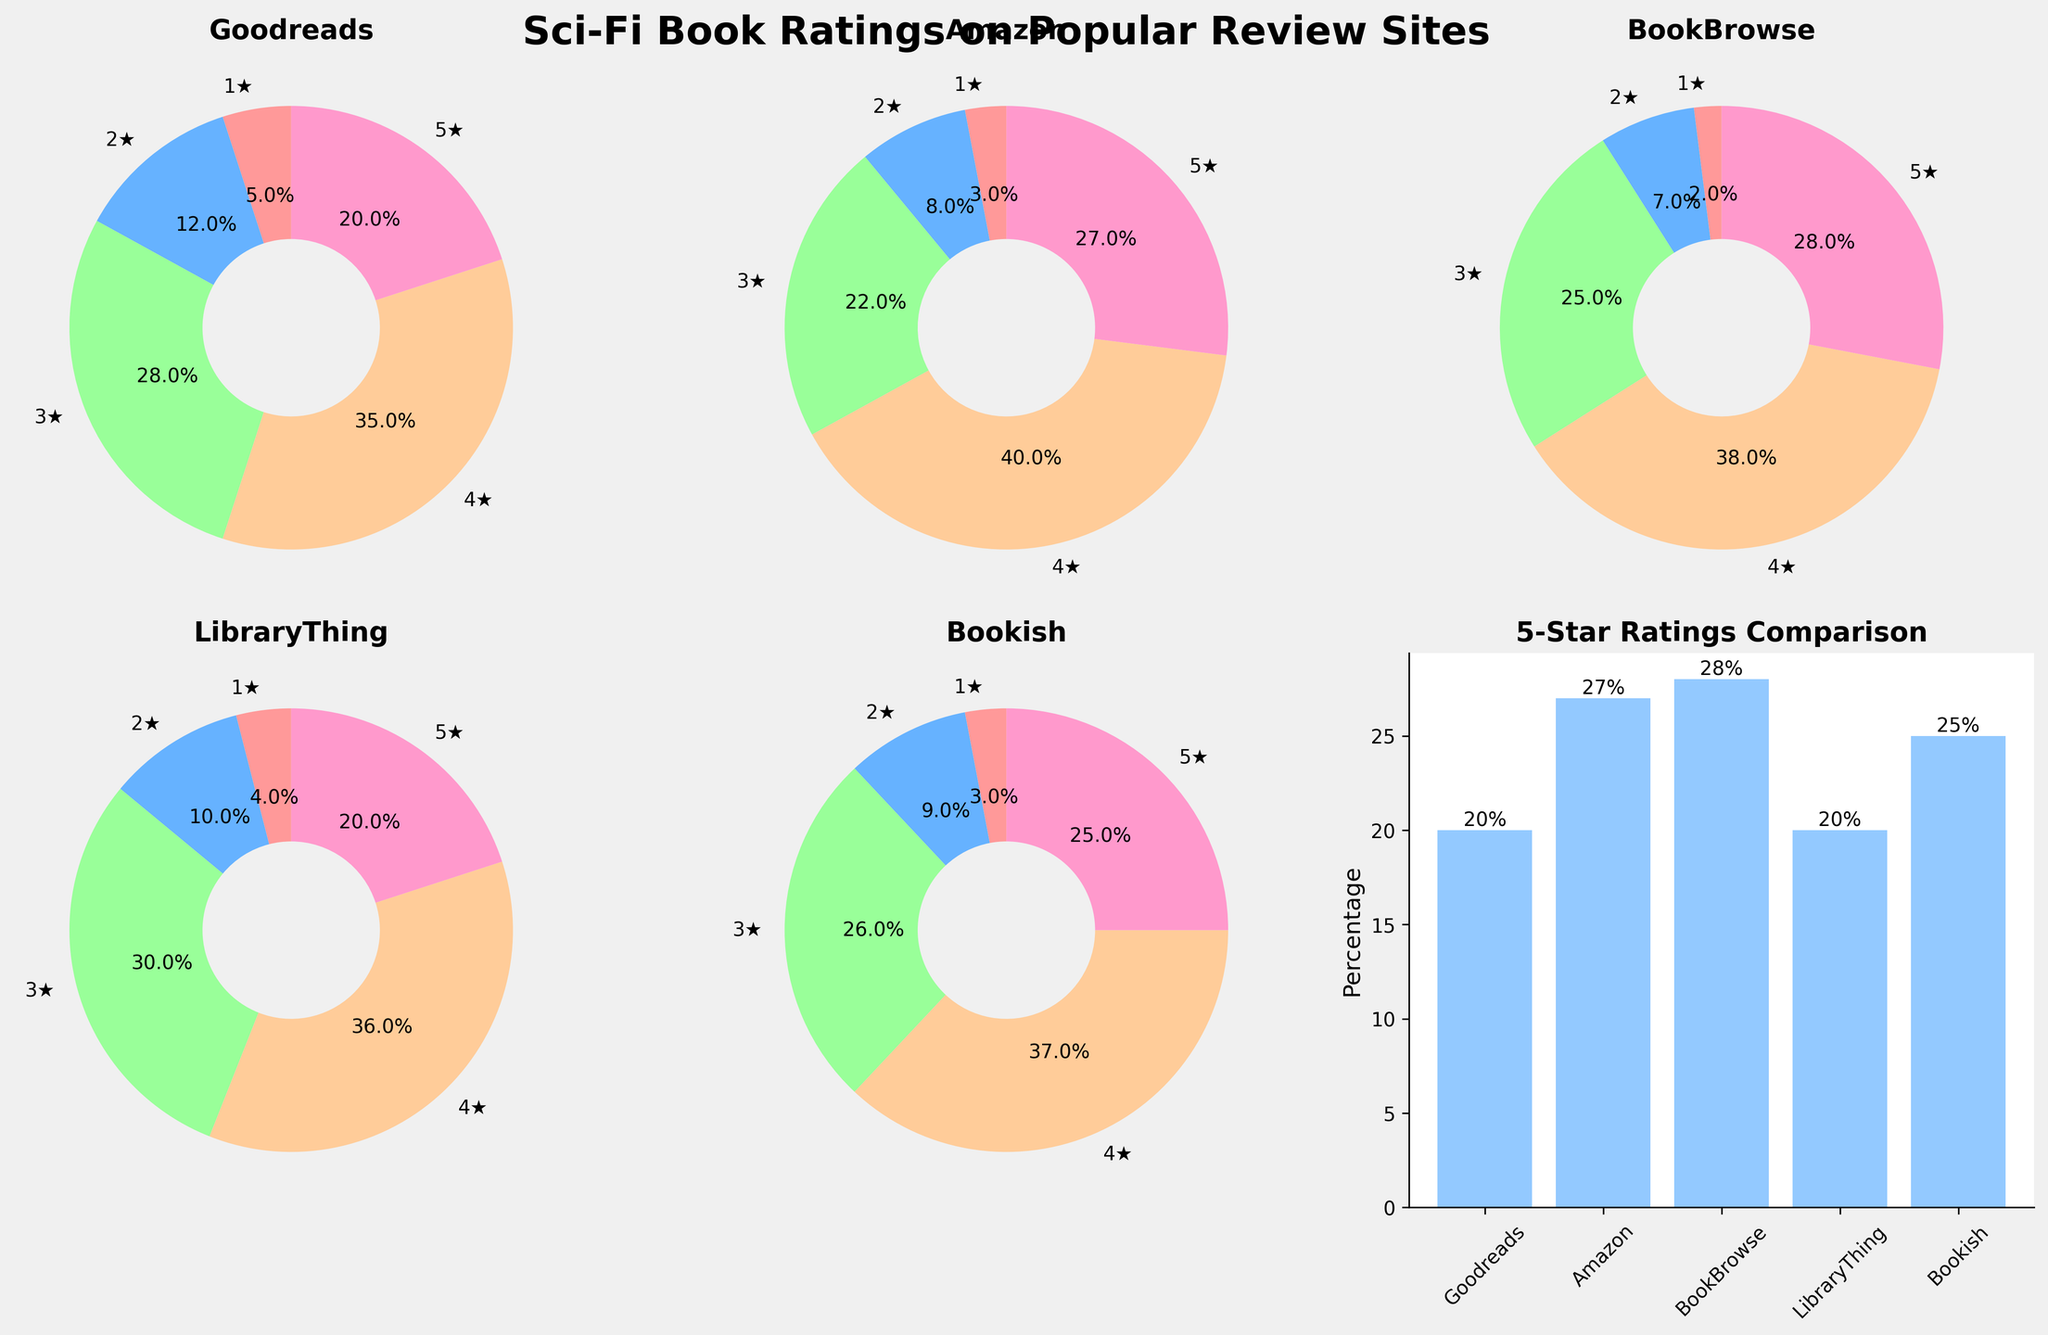How many review sites are analyzed in the figure? The figure has a separate pie chart for each review site, and there is also a bar chart comparing the 5-star ratings. Counting the titles of the pie charts, there are five review sites.
Answer: 5 Which review site has the highest percentage of 5-star ratings? By looking at the percentages in the pie charts for the 5-star ratings (the section labeled '5★'), BookBrowse has the highest, showing 28%.
Answer: BookBrowse What is the total percentage of 1-star ratings across all review sites? Sum up the 1-star ratings from each site: Goodreads (5), Amazon (3), BookBrowse (2), LibraryThing (4), Bookish (3). The total is 5 + 3 + 2 + 4 + 3 = 17.
Answer: 17% Which two review sites have the closest percentages of 3-star ratings? The percentages for 3-star ratings are Goodreads (28%), Amazon (22%), BookBrowse (25%), LibraryThing (30%), and Bookish (26%). BookBrowse (25%) and Bookish (26%) are the closest.
Answer: BookBrowse and Bookish Between Amazon and LibraryThing, which has a higher percentage of 4-star ratings and by how much? The percentages are Amazon (40%) for 4-star and LibraryThing (36%) for 4-star. The difference is 40% - 36% = 4%.
Answer: Amazon by 4% Which review site has the smallest percentage of 2-star ratings? Look at the pie chart sections labeled '2★'. BookBrowse has the smallest percentage with 7%.
Answer: BookBrowse What is the average percentage of 5-star ratings across all review sites? Sum the 5-star ratings percentages from all sites: Goodreads (20%), Amazon (27%), BookBrowse (28%), LibraryThing (20%), Bookish (25%). The total is 20 + 27 + 28 + 20 + 25 = 120. The average is 120/5 = 24%.
Answer: 24% How many review sites have more than 35% of 4-star ratings? Check the 4-star ratings in the pie charts. Goodreads (35%), Amazon (40%), BookBrowse (38%), LibraryThing (36%), and Bookish (37%). All of them have more than 35% except Goodreads.
Answer: 4 